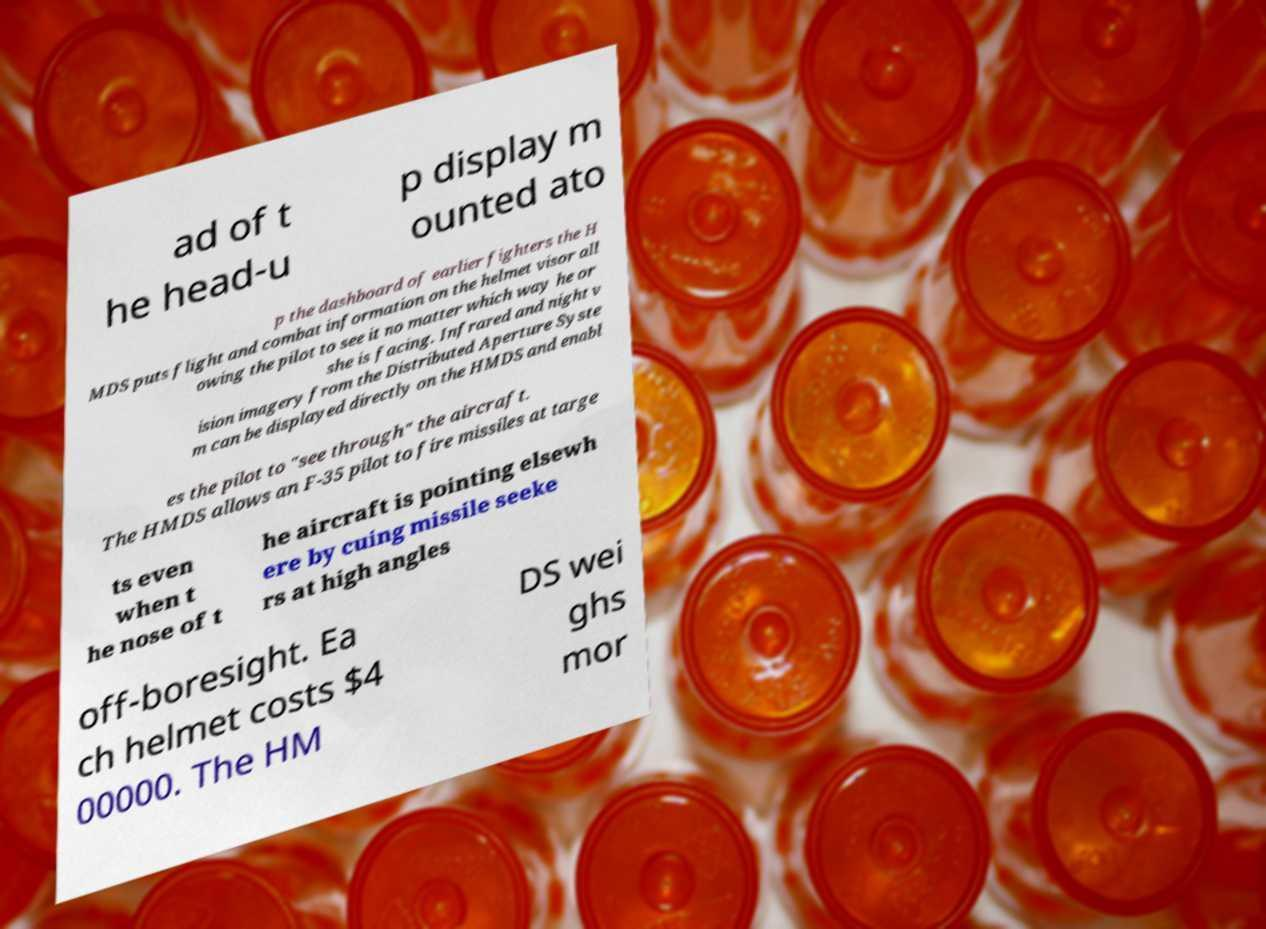There's text embedded in this image that I need extracted. Can you transcribe it verbatim? ad of t he head-u p display m ounted ato p the dashboard of earlier fighters the H MDS puts flight and combat information on the helmet visor all owing the pilot to see it no matter which way he or she is facing. Infrared and night v ision imagery from the Distributed Aperture Syste m can be displayed directly on the HMDS and enabl es the pilot to "see through" the aircraft. The HMDS allows an F-35 pilot to fire missiles at targe ts even when t he nose of t he aircraft is pointing elsewh ere by cuing missile seeke rs at high angles off-boresight. Ea ch helmet costs $4 00000. The HM DS wei ghs mor 